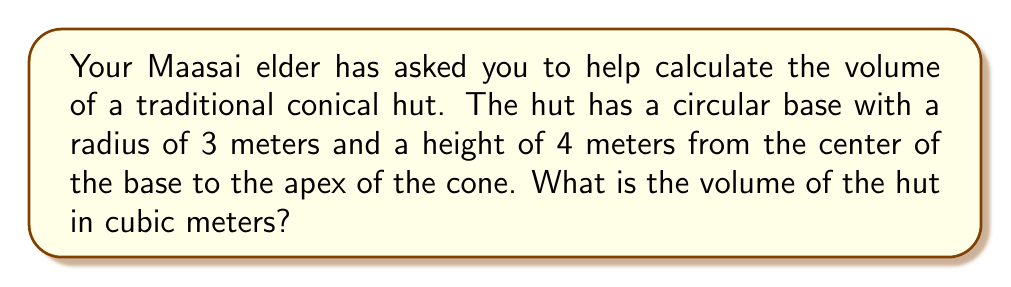Show me your answer to this math problem. Let's approach this step-by-step:

1) The volume of a cone is given by the formula:

   $$V = \frac{1}{3}\pi r^2 h$$

   Where:
   $V$ = volume
   $r$ = radius of the base
   $h$ = height of the cone

2) We are given:
   $r = 3$ meters
   $h = 4$ meters

3) Let's substitute these values into our formula:

   $$V = \frac{1}{3}\pi (3^2) (4)$$

4) Simplify the expression inside the parentheses:

   $$V = \frac{1}{3}\pi (9) (4)$$

5) Multiply:

   $$V = \frac{1}{3}\pi (36)$$

6) Simplify:

   $$V = 12\pi$$

7) If we want to give a decimal approximation, we can calculate this:

   $$V \approx 12 * 3.14159 \approx 37.69908$$

Therefore, the volume of the hut is $12\pi$ cubic meters, or approximately 37.7 cubic meters.

[asy]
import three;

size(200);
currentprojection=perspective(6,3,2);

triple O=(0,0,0), A=(3,0,0), C=(0,0,4);

draw(O--A--C--O,blue);
draw(O--C,dashed);

path3 p=arc(O,A,degrees(90),90);
draw(p,blue);

label("3m",O--A,S);
label("4m",O--C,W);

draw(surface(O--p--O),lightblue+opacity(0.1));
[/asy]
Answer: $12\pi$ cubic meters 